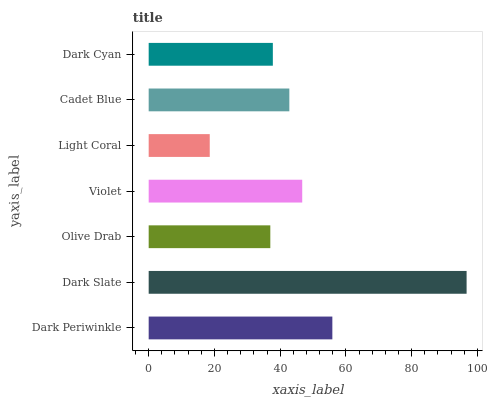Is Light Coral the minimum?
Answer yes or no. Yes. Is Dark Slate the maximum?
Answer yes or no. Yes. Is Olive Drab the minimum?
Answer yes or no. No. Is Olive Drab the maximum?
Answer yes or no. No. Is Dark Slate greater than Olive Drab?
Answer yes or no. Yes. Is Olive Drab less than Dark Slate?
Answer yes or no. Yes. Is Olive Drab greater than Dark Slate?
Answer yes or no. No. Is Dark Slate less than Olive Drab?
Answer yes or no. No. Is Cadet Blue the high median?
Answer yes or no. Yes. Is Cadet Blue the low median?
Answer yes or no. Yes. Is Dark Periwinkle the high median?
Answer yes or no. No. Is Dark Slate the low median?
Answer yes or no. No. 